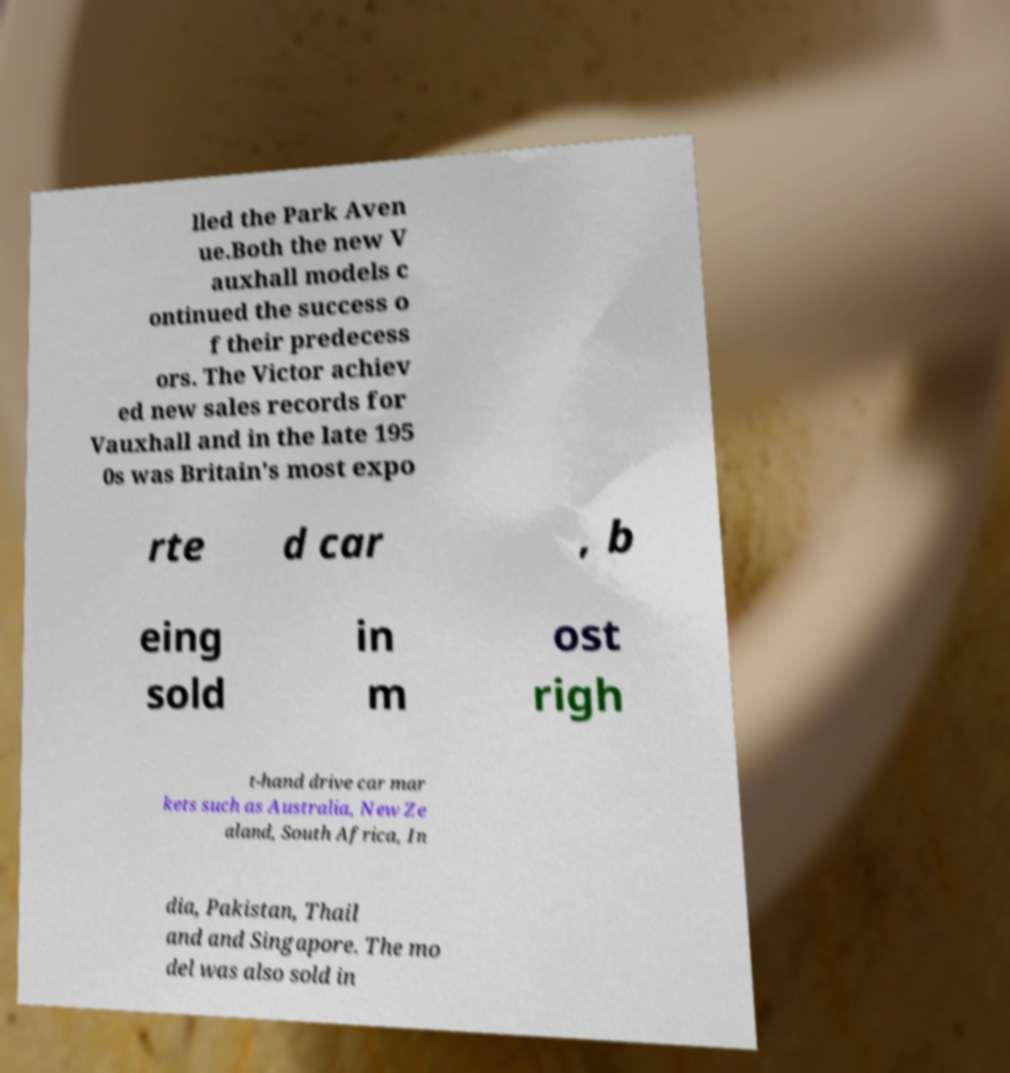There's text embedded in this image that I need extracted. Can you transcribe it verbatim? lled the Park Aven ue.Both the new V auxhall models c ontinued the success o f their predecess ors. The Victor achiev ed new sales records for Vauxhall and in the late 195 0s was Britain's most expo rte d car , b eing sold in m ost righ t-hand drive car mar kets such as Australia, New Ze aland, South Africa, In dia, Pakistan, Thail and and Singapore. The mo del was also sold in 